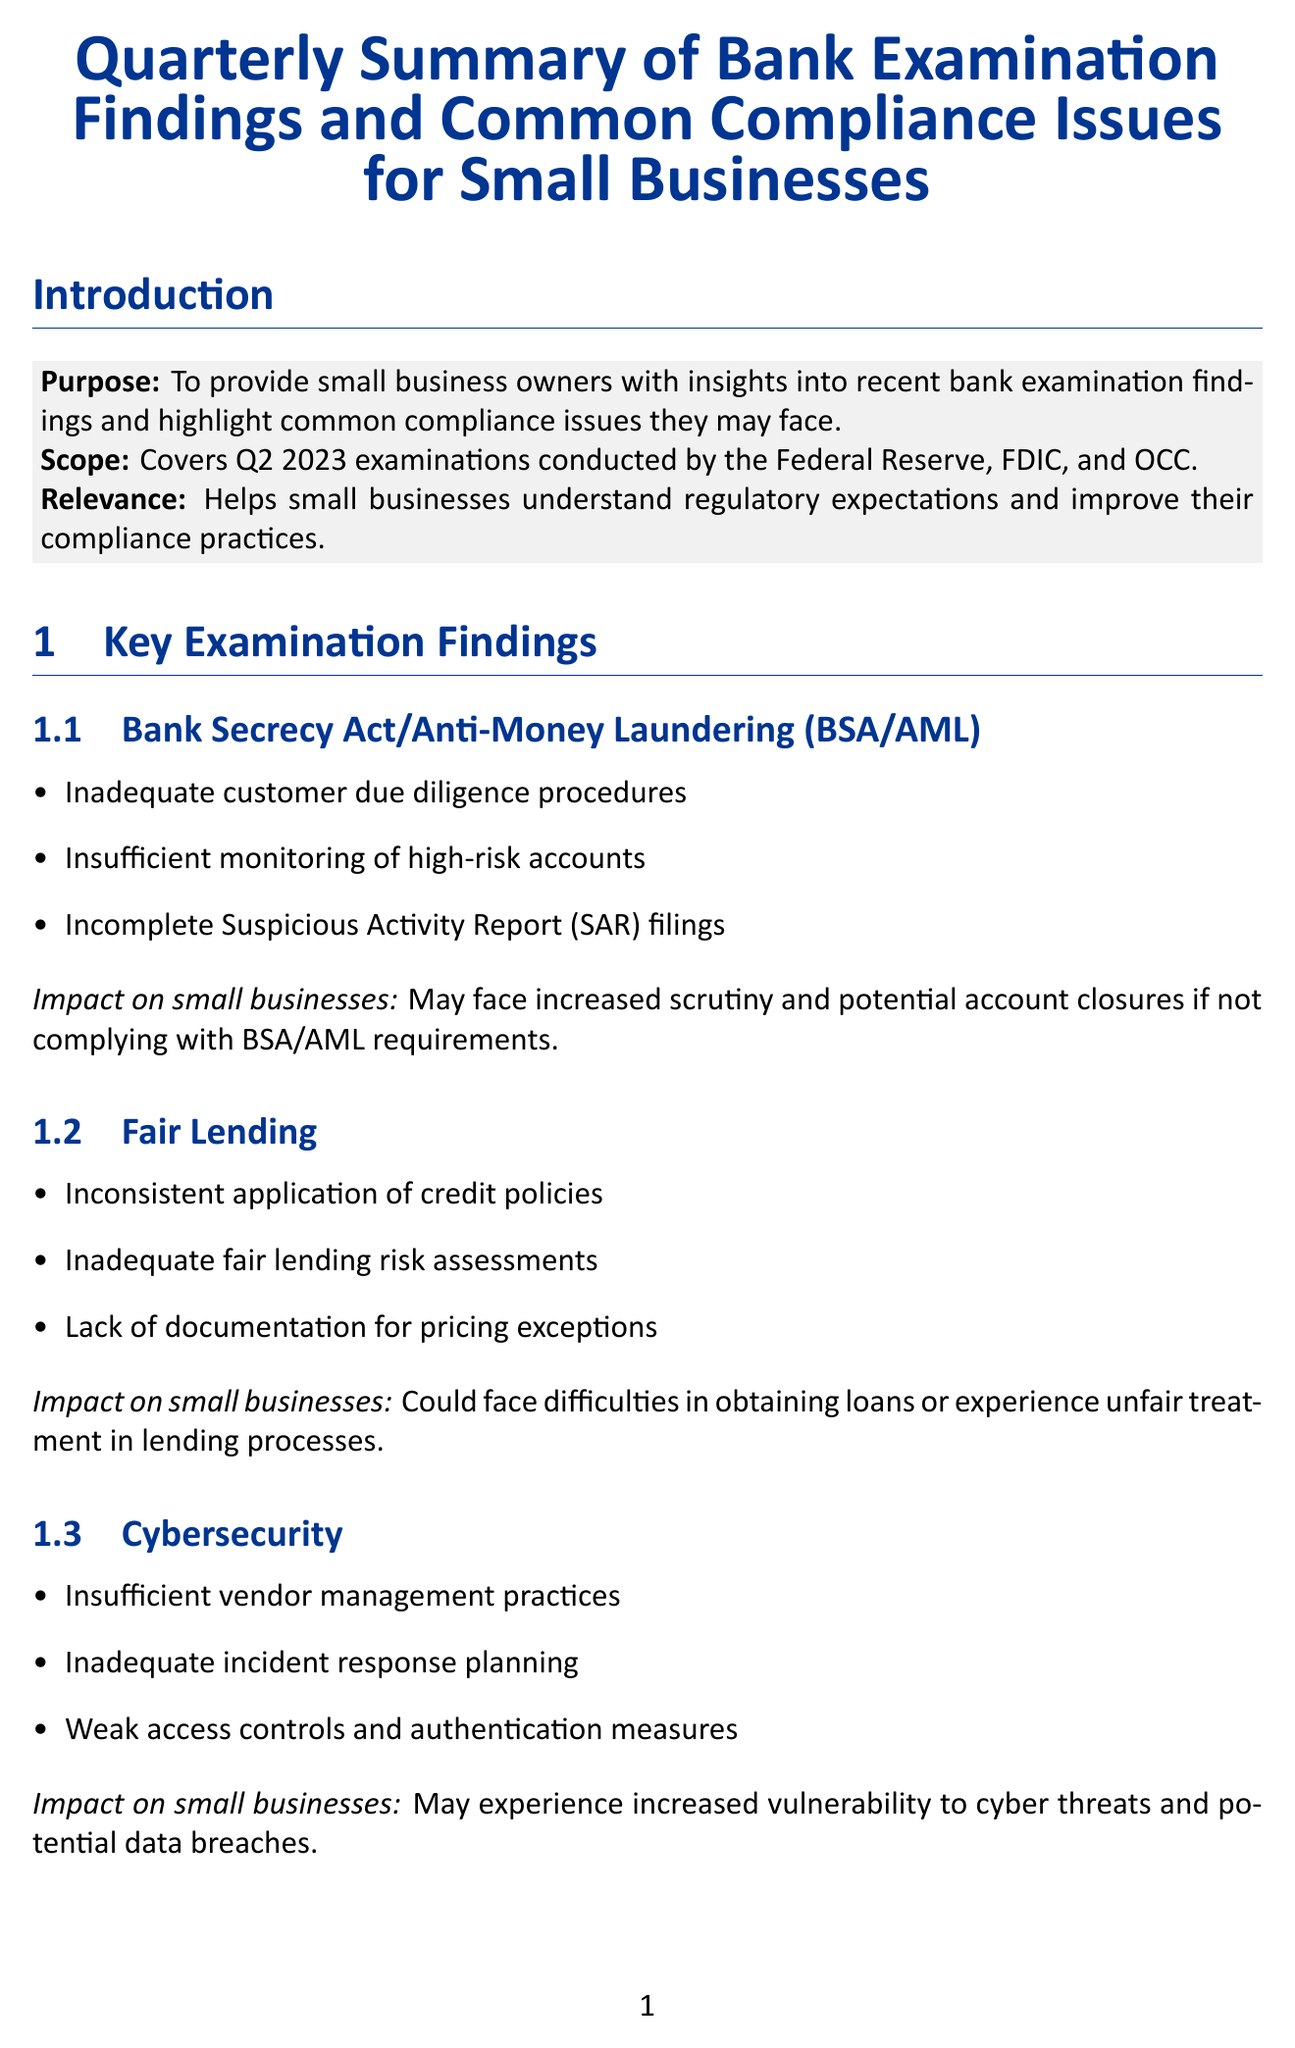What is the purpose of the report? The purpose of the report is to provide small business owners with insights into recent bank examination findings and highlight common compliance issues they may face.
Answer: To provide small business owners with insights into recent bank examination findings and highlight common compliance issues they may face Which agency proposed a rule for small business lending data collection? The rule is proposed by the Consumer Financial Protection Bureau, which is mentioned in the regulatory updates section.
Answer: Consumer Financial Protection Bureau (CFPB) What is a common compliance issue related to payroll? The issue related to payroll is failure to accurately calculate, report, and remit payroll taxes.
Answer: Failure to accurately calculate, report, and remit payroll taxes What impact do BSA/AML compliance issues have on small businesses? The document states that small businesses may face increased scrutiny and potential account closures if not complying with BSA/AML requirements.
Answer: Increased scrutiny and potential account closures List one resource provided for small businesses in the document. The document lists several resources; one example is the SBA Compliance Guide, which covers various compliance areas for small businesses.
Answer: SBA Compliance Guide 